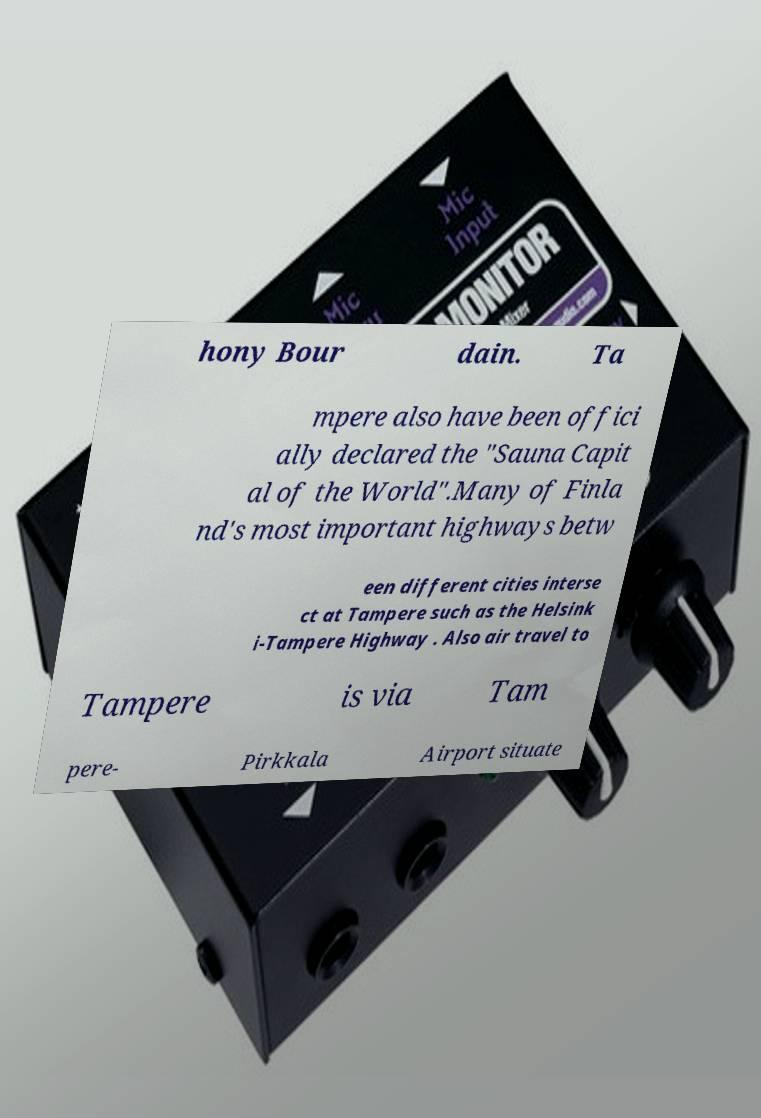Please identify and transcribe the text found in this image. hony Bour dain. Ta mpere also have been offici ally declared the "Sauna Capit al of the World".Many of Finla nd's most important highways betw een different cities interse ct at Tampere such as the Helsink i-Tampere Highway . Also air travel to Tampere is via Tam pere- Pirkkala Airport situate 